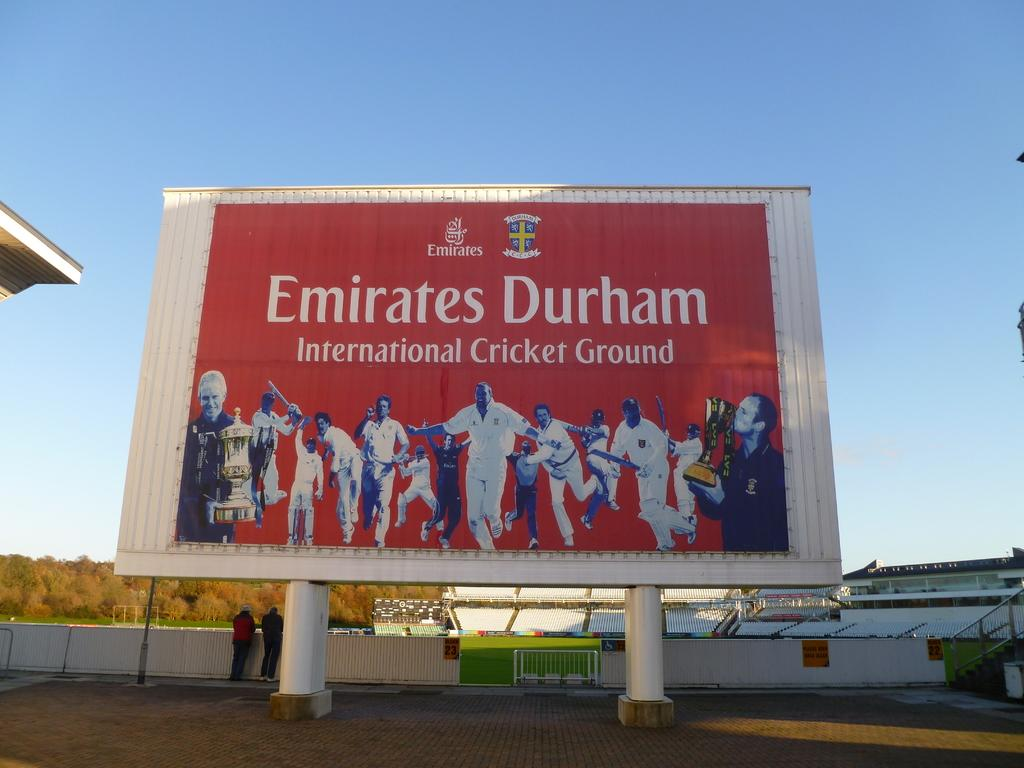<image>
Offer a succinct explanation of the picture presented. A red billboard for the Emirates Durham featuring people running and holding trophies. 